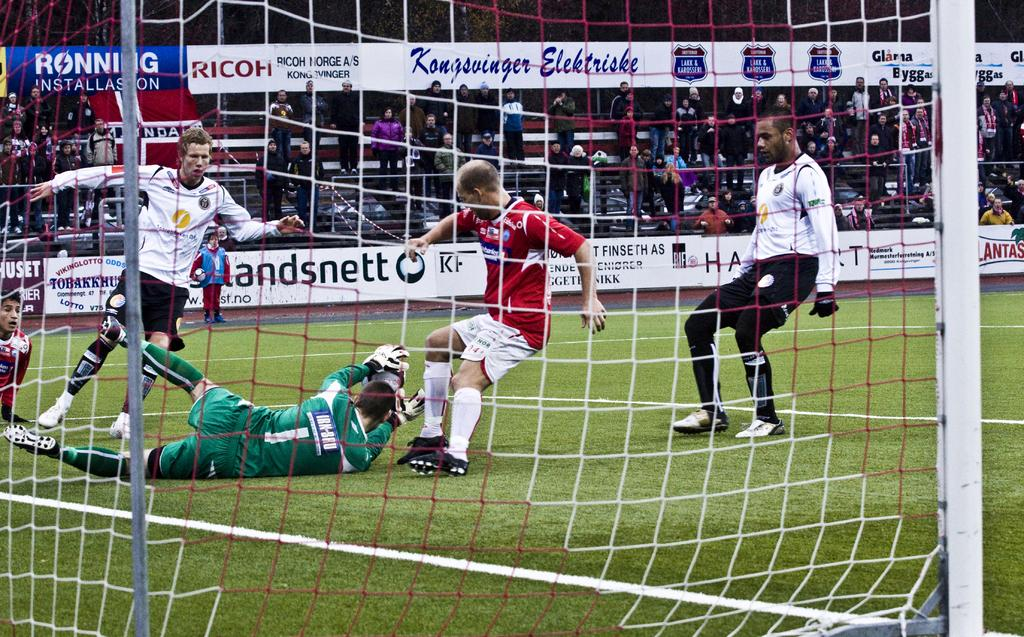Provide a one-sentence caption for the provided image. Players race towards the goal with the ball near a RICOH ad. 